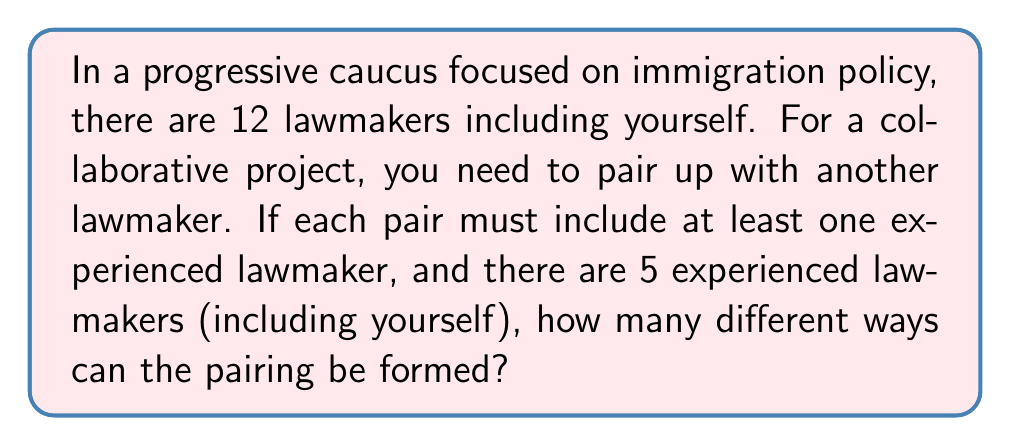What is the answer to this math problem? Let's approach this step-by-step:

1) First, we need to consider that you are one of the experienced lawmakers and you must be in a pair.

2) You have two options:
   a) Pair with another experienced lawmaker
   b) Pair with a non-experienced lawmaker

3) If you pair with another experienced lawmaker:
   - There are 4 other experienced lawmakers to choose from
   - Number of ways = $4$

4) If you pair with a non-experienced lawmaker:
   - There are 7 non-experienced lawmakers to choose from
   - Number of ways = $7$

5) The total number of ways you can be paired is the sum of these two options:

   $$ 4 + 7 = 11 $$

Therefore, there are 11 different ways the pairing can be formed.
Answer: 11 